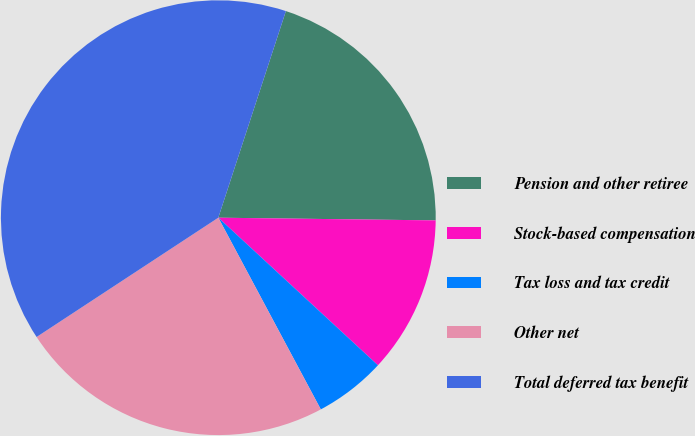<chart> <loc_0><loc_0><loc_500><loc_500><pie_chart><fcel>Pension and other retiree<fcel>Stock-based compensation<fcel>Tax loss and tax credit<fcel>Other net<fcel>Total deferred tax benefit<nl><fcel>20.17%<fcel>11.68%<fcel>5.31%<fcel>23.57%<fcel>39.28%<nl></chart> 